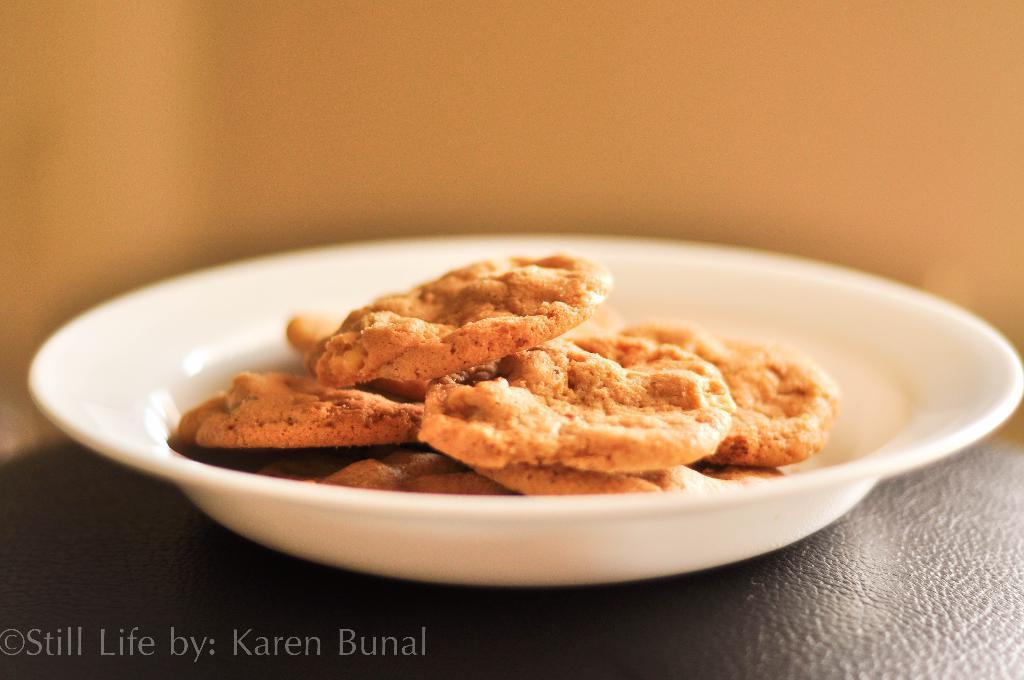How would you summarize this image in a sentence or two? In the image in the center, we can see one table. On the table, there is a plate. In the plate, we can see some food items. At the left bottom of the image, there is a watermark. In the background there is a wall. 